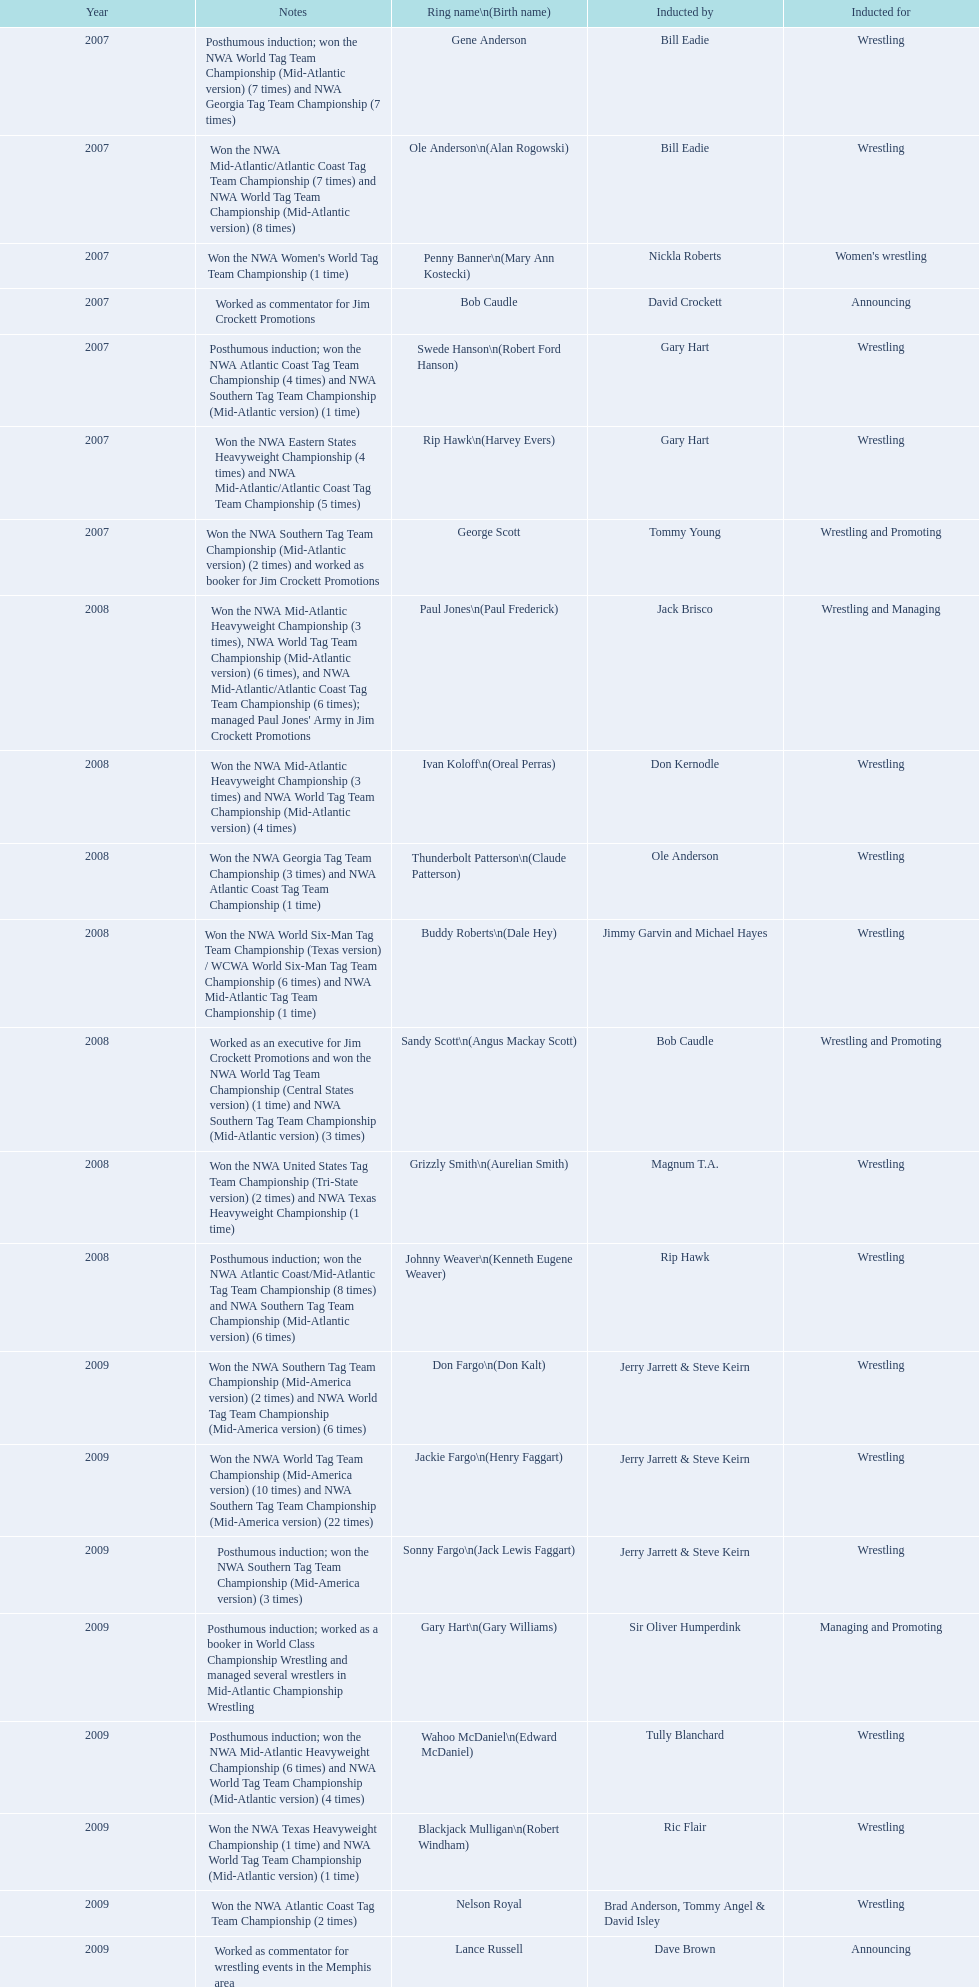What announcers were inducted? Bob Caudle, Lance Russell. What announcer was inducted in 2009? Lance Russell. 